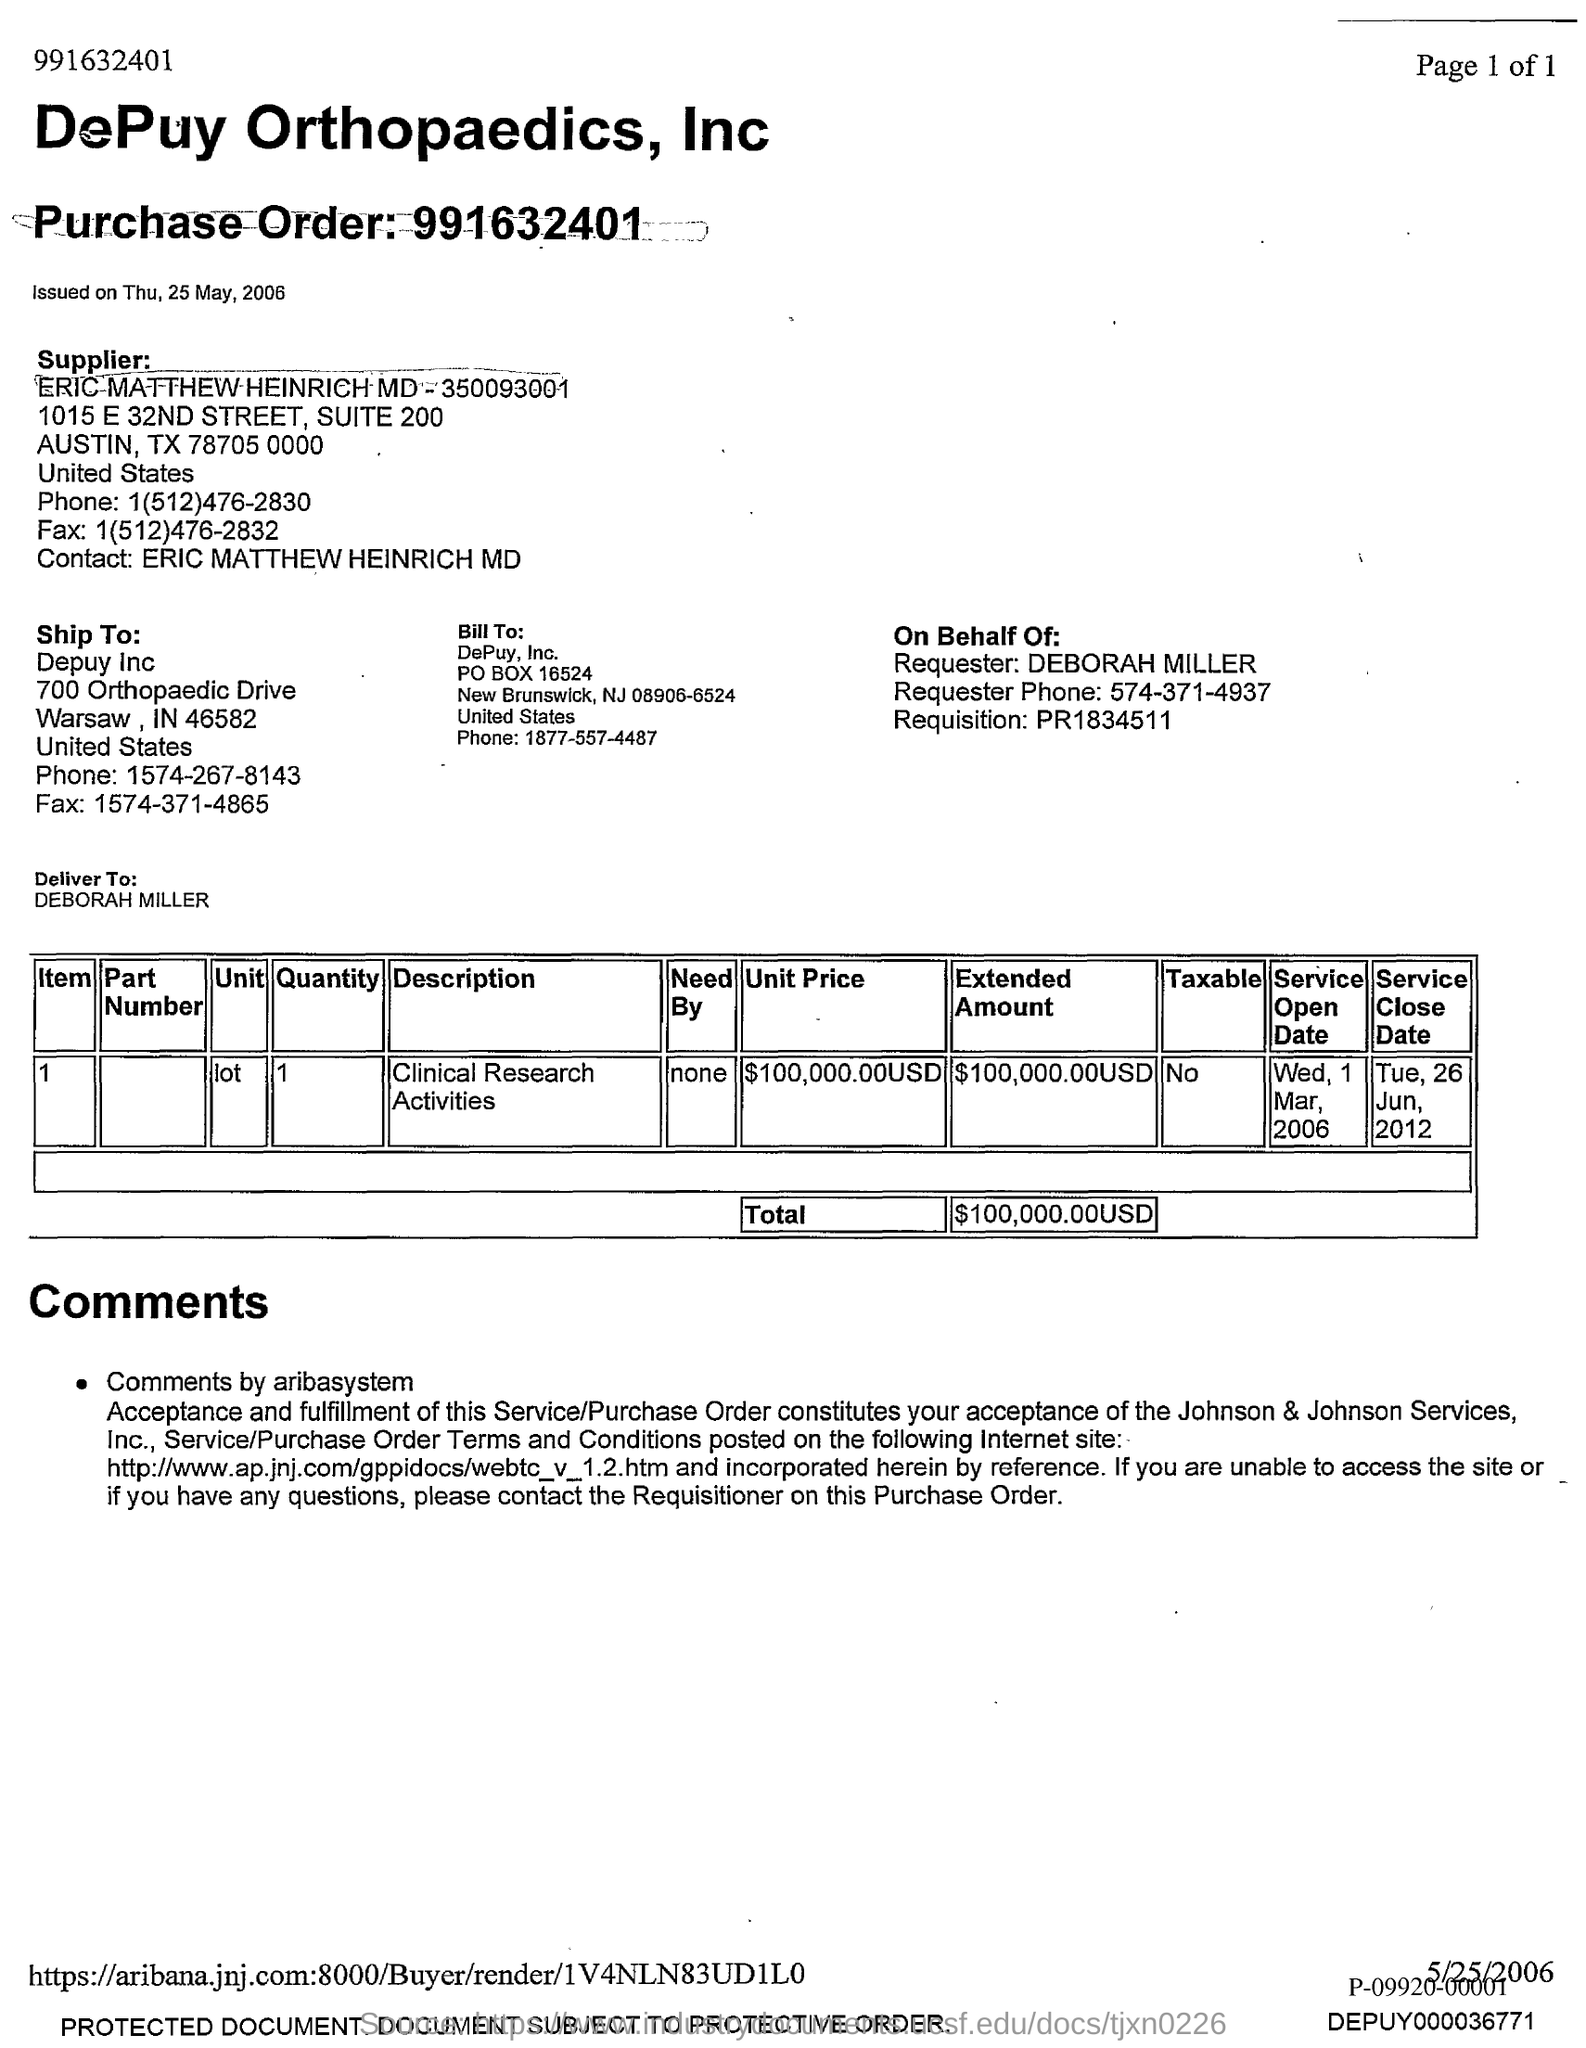What is the Purchase Order?
Your answer should be very brief. 991632401. When was it issued on?
Provide a short and direct response. Thu, 25 may, 2006. Who is the Ship to.?
Your answer should be compact. Depuy Inc. 